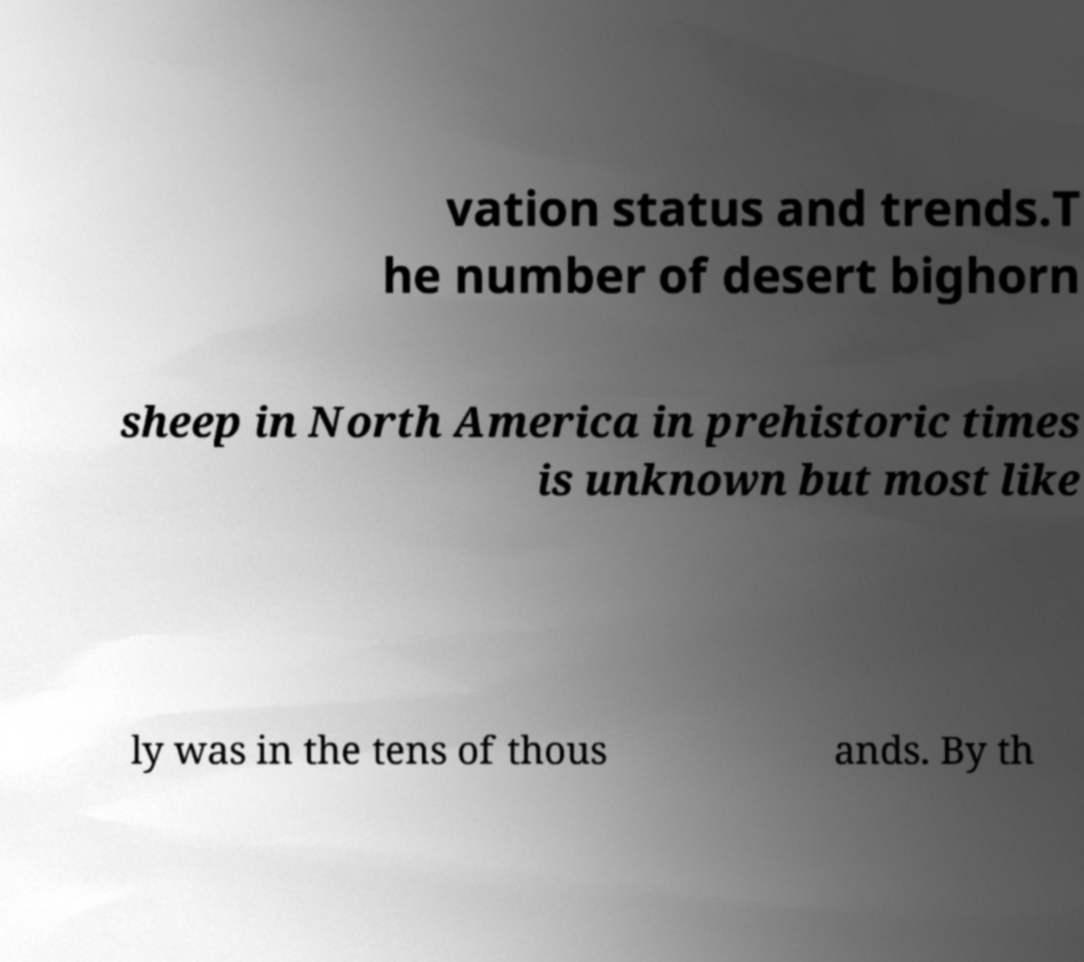What messages or text are displayed in this image? I need them in a readable, typed format. vation status and trends.T he number of desert bighorn sheep in North America in prehistoric times is unknown but most like ly was in the tens of thous ands. By th 